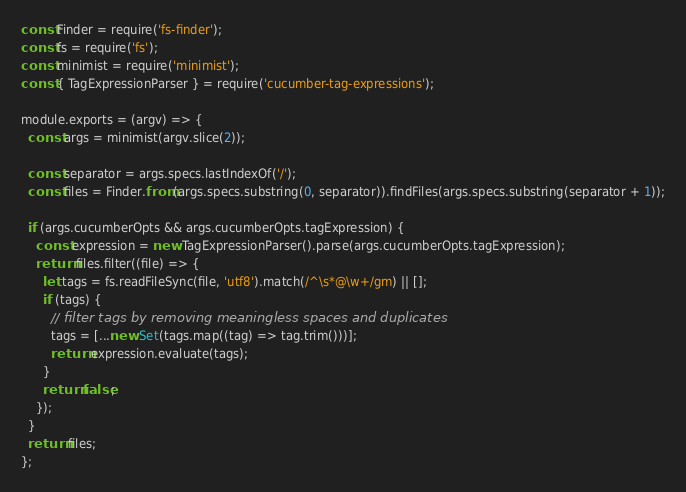<code> <loc_0><loc_0><loc_500><loc_500><_JavaScript_>const Finder = require('fs-finder');
const fs = require('fs');
const minimist = require('minimist');
const { TagExpressionParser } = require('cucumber-tag-expressions');

module.exports = (argv) => {
  const args = minimist(argv.slice(2));

  const separator = args.specs.lastIndexOf('/');
  const files = Finder.from(args.specs.substring(0, separator)).findFiles(args.specs.substring(separator + 1));

  if (args.cucumberOpts && args.cucumberOpts.tagExpression) {
    const expression = new TagExpressionParser().parse(args.cucumberOpts.tagExpression);
    return files.filter((file) => {
      let tags = fs.readFileSync(file, 'utf8').match(/^\s*@\w+/gm) || [];
      if (tags) {
        // filter tags by removing meaningless spaces and duplicates
        tags = [...new Set(tags.map((tag) => tag.trim()))];
        return expression.evaluate(tags);
      }
      return false;
    });
  }
  return files;
};
</code> 